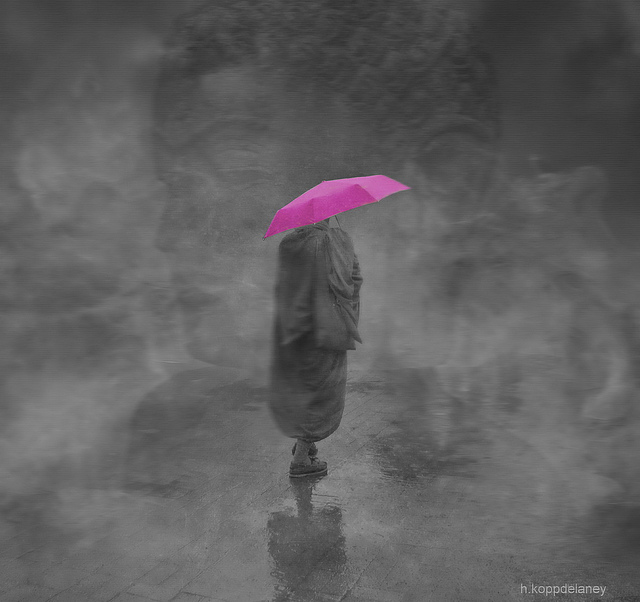What could the solitary figure under the umbrella represent in an artistic or symbolic sense? Artistically, the solitary figure suggests themes of solitude, introspection, or even quiet resilience. Symbolically, the individual could represent the human experience of navigating through life's challenges shielded by their unique perspective, represented by the distinct, colorful umbrella. It might also denote a journey through a vague or unclear world, with the umbrella being a metaphor for personal beliefs or ideals that protect and distinguish the individual. Does the image suggest a particular time of day or weather condition? The overall gray tone and the presence of reflections on the ground suggest overcast weather conditions, often associated with rain. The blurring and lack of distinct shadows do not specify a time of day but contribute to an ambiguous, gloomy atmosphere that could pertain to early morning or late afternoon, aligning with times when rain is common. 